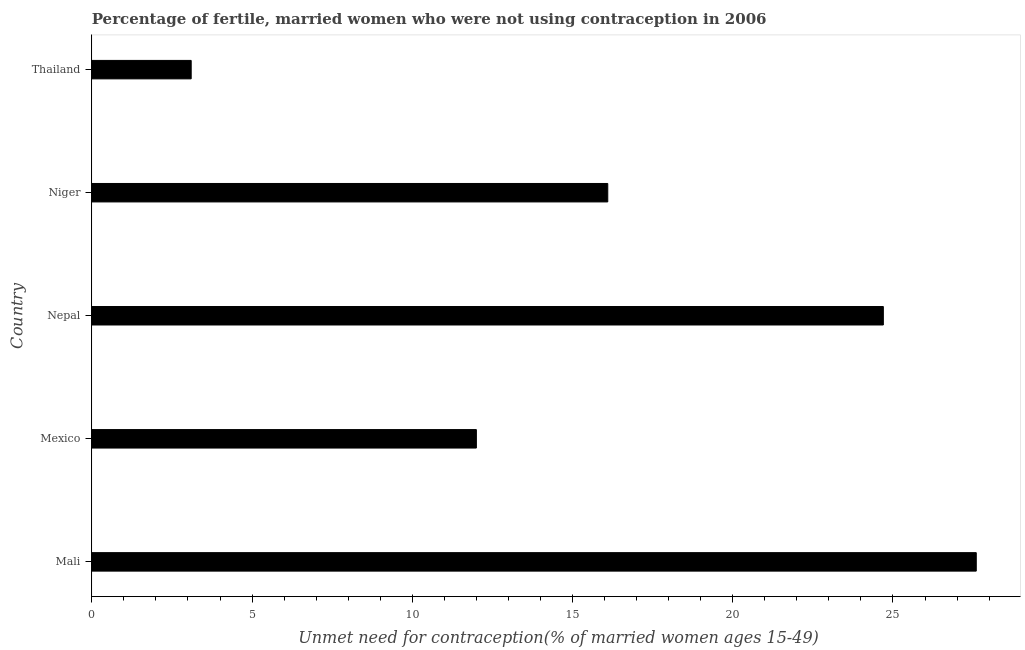What is the title of the graph?
Offer a terse response. Percentage of fertile, married women who were not using contraception in 2006. What is the label or title of the X-axis?
Your answer should be compact.  Unmet need for contraception(% of married women ages 15-49). What is the number of married women who are not using contraception in Thailand?
Your answer should be very brief. 3.1. Across all countries, what is the maximum number of married women who are not using contraception?
Offer a terse response. 27.6. In which country was the number of married women who are not using contraception maximum?
Give a very brief answer. Mali. In which country was the number of married women who are not using contraception minimum?
Make the answer very short. Thailand. What is the sum of the number of married women who are not using contraception?
Make the answer very short. 83.5. What is the difference between the number of married women who are not using contraception in Niger and Thailand?
Offer a terse response. 13. What is the average number of married women who are not using contraception per country?
Make the answer very short. 16.7. What is the median number of married women who are not using contraception?
Offer a very short reply. 16.1. What is the ratio of the number of married women who are not using contraception in Mali to that in Thailand?
Keep it short and to the point. 8.9. Is the number of married women who are not using contraception in Mali less than that in Niger?
Your response must be concise. No. What is the difference between the highest and the second highest number of married women who are not using contraception?
Your answer should be compact. 2.9. Is the sum of the number of married women who are not using contraception in Mexico and Niger greater than the maximum number of married women who are not using contraception across all countries?
Provide a short and direct response. Yes. How many bars are there?
Give a very brief answer. 5. Are the values on the major ticks of X-axis written in scientific E-notation?
Your answer should be compact. No. What is the  Unmet need for contraception(% of married women ages 15-49) in Mali?
Provide a short and direct response. 27.6. What is the  Unmet need for contraception(% of married women ages 15-49) of Mexico?
Offer a very short reply. 12. What is the  Unmet need for contraception(% of married women ages 15-49) of Nepal?
Keep it short and to the point. 24.7. What is the  Unmet need for contraception(% of married women ages 15-49) in Thailand?
Make the answer very short. 3.1. What is the difference between the  Unmet need for contraception(% of married women ages 15-49) in Mali and Mexico?
Offer a terse response. 15.6. What is the difference between the  Unmet need for contraception(% of married women ages 15-49) in Mali and Nepal?
Provide a short and direct response. 2.9. What is the difference between the  Unmet need for contraception(% of married women ages 15-49) in Mali and Niger?
Give a very brief answer. 11.5. What is the difference between the  Unmet need for contraception(% of married women ages 15-49) in Mali and Thailand?
Provide a succinct answer. 24.5. What is the difference between the  Unmet need for contraception(% of married women ages 15-49) in Mexico and Niger?
Give a very brief answer. -4.1. What is the difference between the  Unmet need for contraception(% of married women ages 15-49) in Mexico and Thailand?
Make the answer very short. 8.9. What is the difference between the  Unmet need for contraception(% of married women ages 15-49) in Nepal and Niger?
Your response must be concise. 8.6. What is the difference between the  Unmet need for contraception(% of married women ages 15-49) in Nepal and Thailand?
Give a very brief answer. 21.6. What is the ratio of the  Unmet need for contraception(% of married women ages 15-49) in Mali to that in Nepal?
Offer a terse response. 1.12. What is the ratio of the  Unmet need for contraception(% of married women ages 15-49) in Mali to that in Niger?
Provide a short and direct response. 1.71. What is the ratio of the  Unmet need for contraception(% of married women ages 15-49) in Mali to that in Thailand?
Your answer should be compact. 8.9. What is the ratio of the  Unmet need for contraception(% of married women ages 15-49) in Mexico to that in Nepal?
Ensure brevity in your answer.  0.49. What is the ratio of the  Unmet need for contraception(% of married women ages 15-49) in Mexico to that in Niger?
Offer a very short reply. 0.74. What is the ratio of the  Unmet need for contraception(% of married women ages 15-49) in Mexico to that in Thailand?
Make the answer very short. 3.87. What is the ratio of the  Unmet need for contraception(% of married women ages 15-49) in Nepal to that in Niger?
Provide a short and direct response. 1.53. What is the ratio of the  Unmet need for contraception(% of married women ages 15-49) in Nepal to that in Thailand?
Ensure brevity in your answer.  7.97. What is the ratio of the  Unmet need for contraception(% of married women ages 15-49) in Niger to that in Thailand?
Provide a short and direct response. 5.19. 